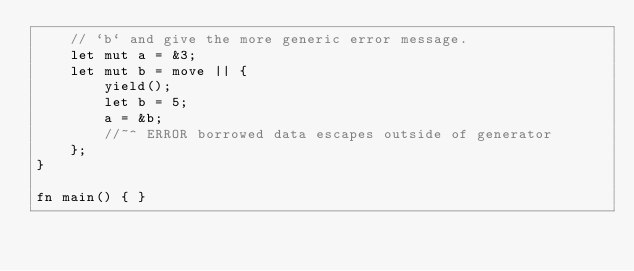<code> <loc_0><loc_0><loc_500><loc_500><_Rust_>    // `b` and give the more generic error message.
    let mut a = &3;
    let mut b = move || {
        yield();
        let b = 5;
        a = &b;
        //~^ ERROR borrowed data escapes outside of generator
    };
}

fn main() { }
</code> 